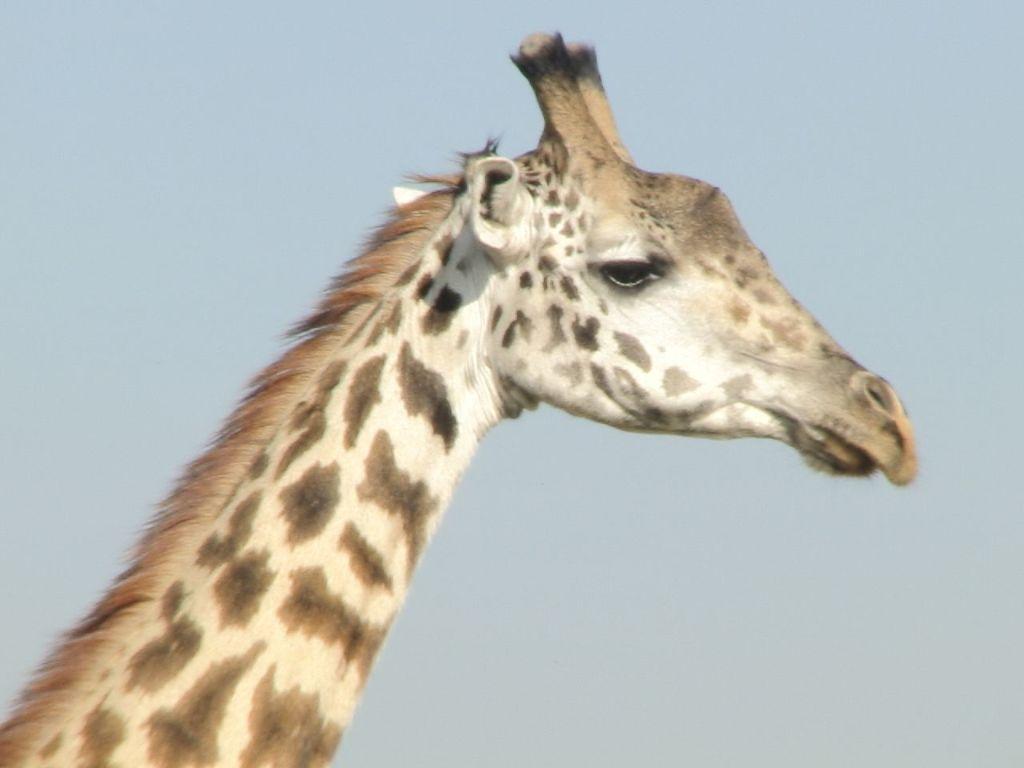Describe this image in one or two sentences. In this image in front there is a giraffe. In the background of the image there is sky. 